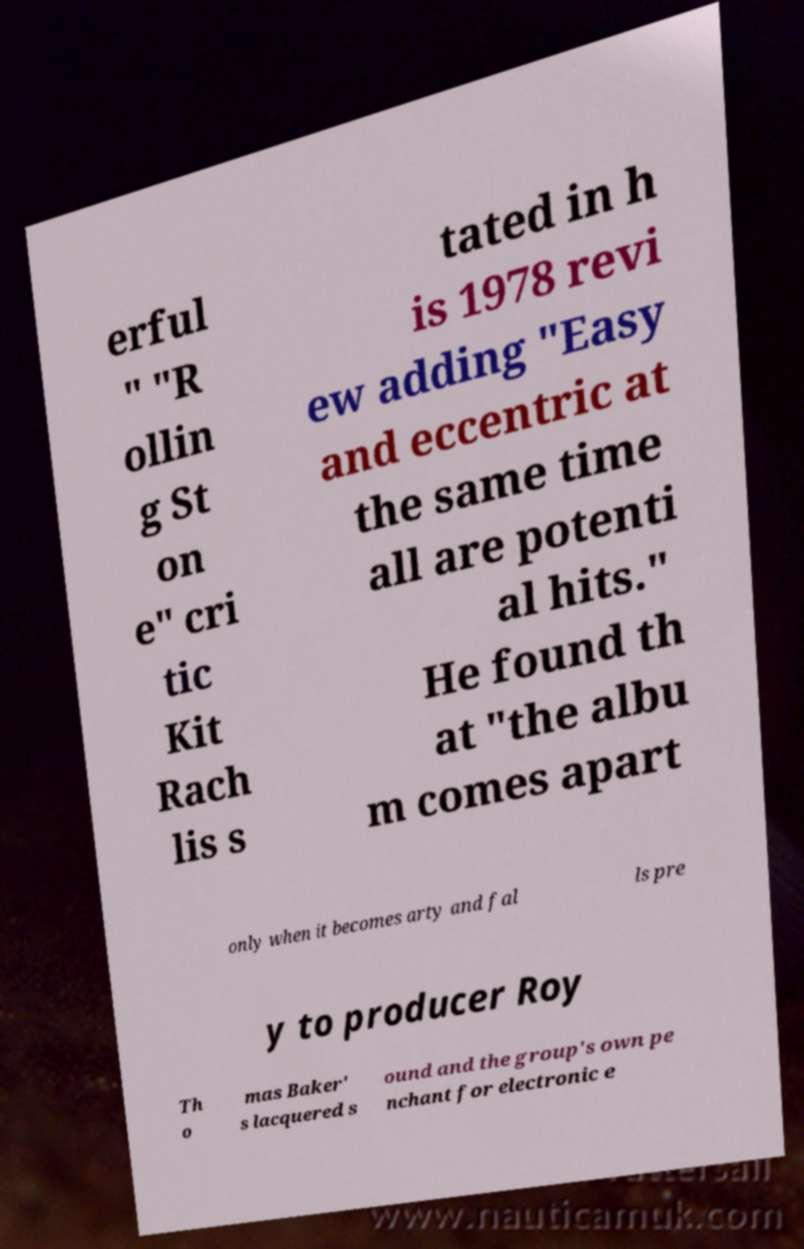For documentation purposes, I need the text within this image transcribed. Could you provide that? erful " "R ollin g St on e" cri tic Kit Rach lis s tated in h is 1978 revi ew adding "Easy and eccentric at the same time all are potenti al hits." He found th at "the albu m comes apart only when it becomes arty and fal ls pre y to producer Roy Th o mas Baker' s lacquered s ound and the group's own pe nchant for electronic e 